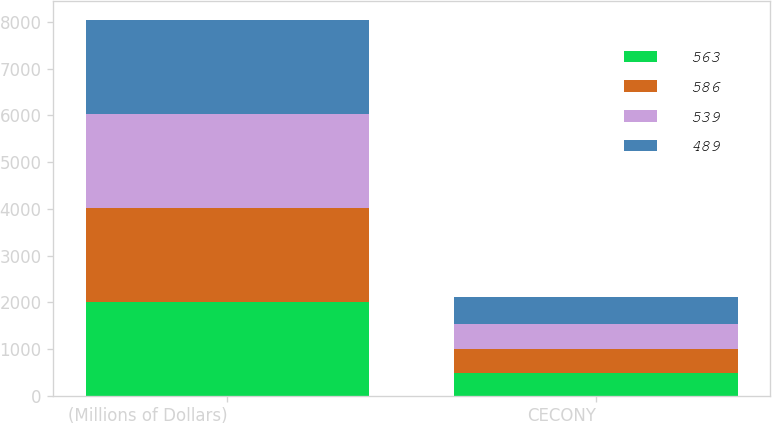Convert chart to OTSL. <chart><loc_0><loc_0><loc_500><loc_500><stacked_bar_chart><ecel><fcel>(Millions of Dollars)<fcel>CECONY<nl><fcel>563<fcel>2012<fcel>489<nl><fcel>586<fcel>2013<fcel>515<nl><fcel>539<fcel>2014<fcel>539<nl><fcel>489<fcel>2015<fcel>563<nl></chart> 